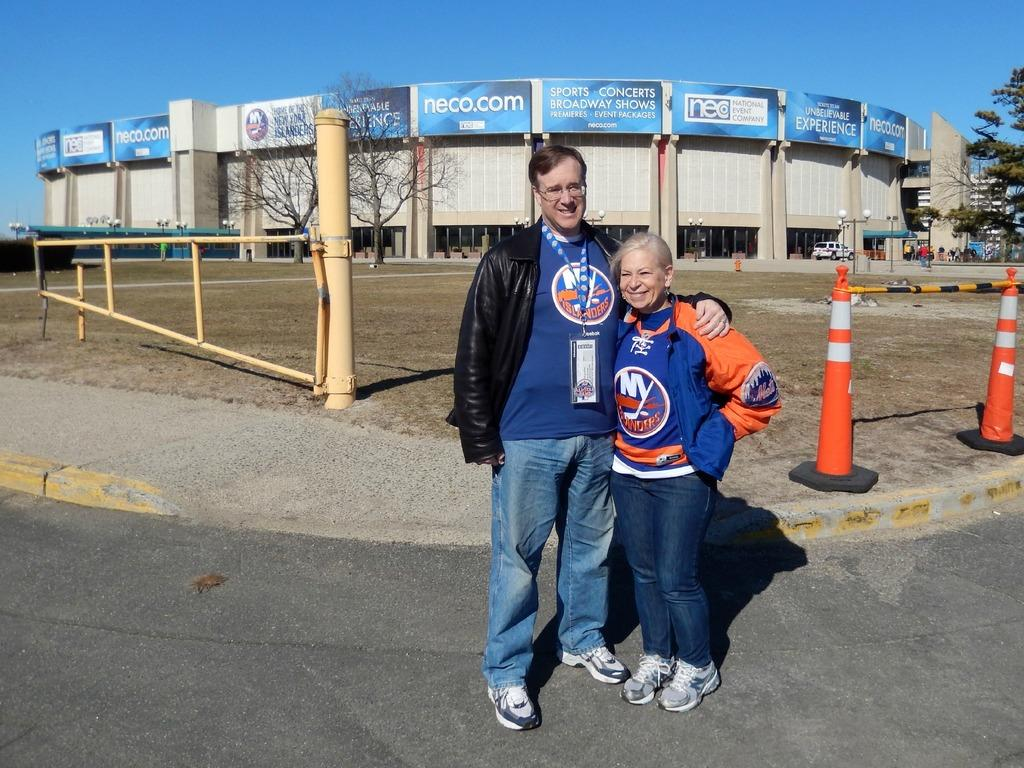<image>
Write a terse but informative summary of the picture. Two people posing for a photo in front of a stadium that says Neco on it. 